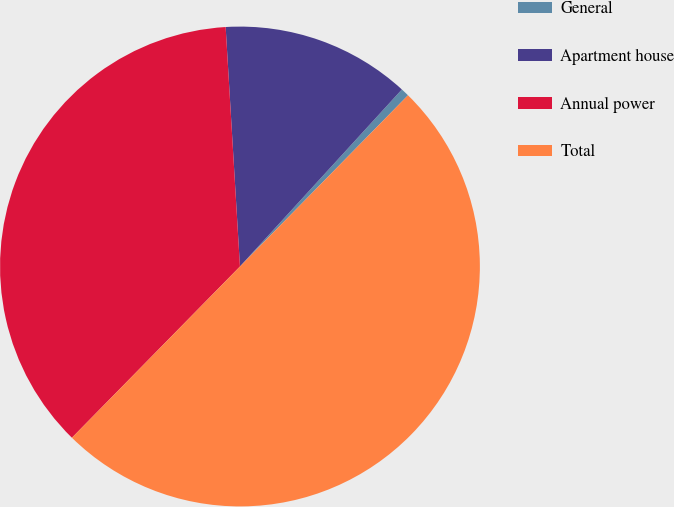Convert chart to OTSL. <chart><loc_0><loc_0><loc_500><loc_500><pie_chart><fcel>General<fcel>Apartment house<fcel>Annual power<fcel>Total<nl><fcel>0.56%<fcel>12.74%<fcel>36.7%<fcel>50.0%<nl></chart> 